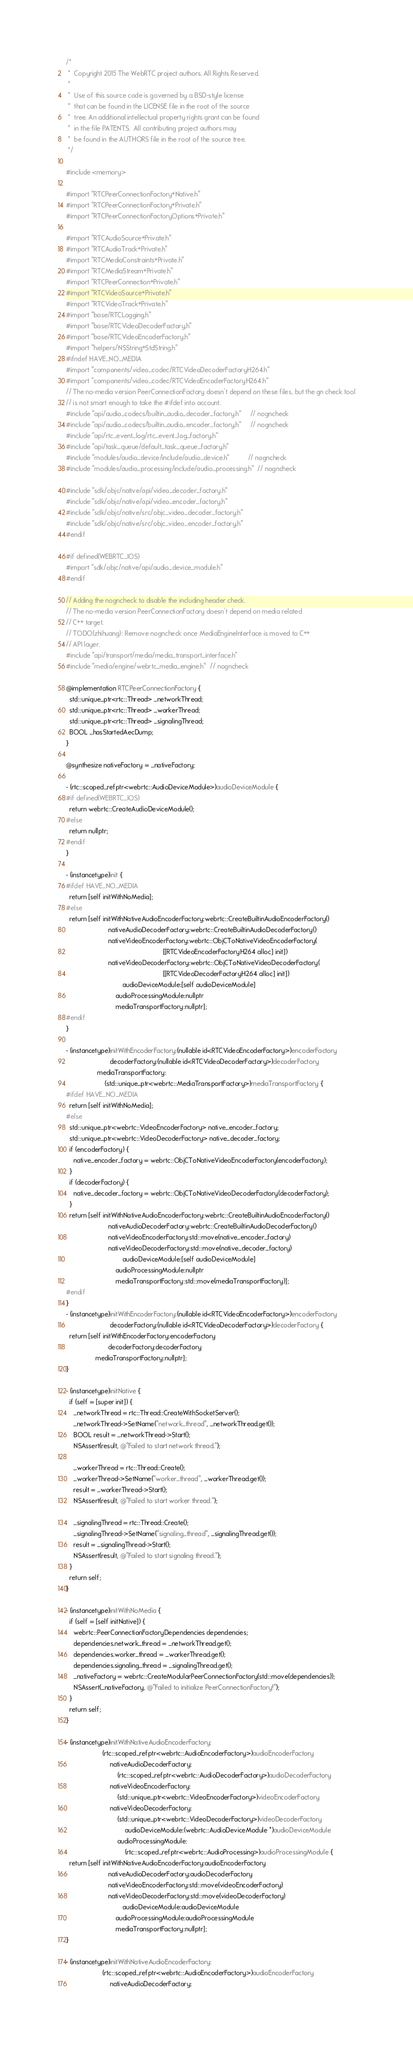<code> <loc_0><loc_0><loc_500><loc_500><_ObjectiveC_>/*
 *  Copyright 2015 The WebRTC project authors. All Rights Reserved.
 *
 *  Use of this source code is governed by a BSD-style license
 *  that can be found in the LICENSE file in the root of the source
 *  tree. An additional intellectual property rights grant can be found
 *  in the file PATENTS.  All contributing project authors may
 *  be found in the AUTHORS file in the root of the source tree.
 */

#include <memory>

#import "RTCPeerConnectionFactory+Native.h"
#import "RTCPeerConnectionFactory+Private.h"
#import "RTCPeerConnectionFactoryOptions+Private.h"

#import "RTCAudioSource+Private.h"
#import "RTCAudioTrack+Private.h"
#import "RTCMediaConstraints+Private.h"
#import "RTCMediaStream+Private.h"
#import "RTCPeerConnection+Private.h"
#import "RTCVideoSource+Private.h"
#import "RTCVideoTrack+Private.h"
#import "base/RTCLogging.h"
#import "base/RTCVideoDecoderFactory.h"
#import "base/RTCVideoEncoderFactory.h"
#import "helpers/NSString+StdString.h"
#ifndef HAVE_NO_MEDIA
#import "components/video_codec/RTCVideoDecoderFactoryH264.h"
#import "components/video_codec/RTCVideoEncoderFactoryH264.h"
// The no-media version PeerConnectionFactory doesn't depend on these files, but the gn check tool
// is not smart enough to take the #ifdef into account.
#include "api/audio_codecs/builtin_audio_decoder_factory.h"     // nogncheck
#include "api/audio_codecs/builtin_audio_encoder_factory.h"     // nogncheck
#include "api/rtc_event_log/rtc_event_log_factory.h"
#include "api/task_queue/default_task_queue_factory.h"
#include "modules/audio_device/include/audio_device.h"          // nogncheck
#include "modules/audio_processing/include/audio_processing.h"  // nogncheck

#include "sdk/objc/native/api/video_decoder_factory.h"
#include "sdk/objc/native/api/video_encoder_factory.h"
#include "sdk/objc/native/src/objc_video_decoder_factory.h"
#include "sdk/objc/native/src/objc_video_encoder_factory.h"
#endif

#if defined(WEBRTC_IOS)
#import "sdk/objc/native/api/audio_device_module.h"
#endif

// Adding the nogncheck to disable the including header check.
// The no-media version PeerConnectionFactory doesn't depend on media related
// C++ target.
// TODO(zhihuang): Remove nogncheck once MediaEngineInterface is moved to C++
// API layer.
#include "api/transport/media/media_transport_interface.h"
#include "media/engine/webrtc_media_engine.h"  // nogncheck

@implementation RTCPeerConnectionFactory {
  std::unique_ptr<rtc::Thread> _networkThread;
  std::unique_ptr<rtc::Thread> _workerThread;
  std::unique_ptr<rtc::Thread> _signalingThread;
  BOOL _hasStartedAecDump;
}

@synthesize nativeFactory = _nativeFactory;

- (rtc::scoped_refptr<webrtc::AudioDeviceModule>)audioDeviceModule {
#if defined(WEBRTC_IOS)
  return webrtc::CreateAudioDeviceModule();
#else
  return nullptr;
#endif
}

- (instancetype)init {
#ifdef HAVE_NO_MEDIA
  return [self initWithNoMedia];
#else
  return [self initWithNativeAudioEncoderFactory:webrtc::CreateBuiltinAudioEncoderFactory()
                       nativeAudioDecoderFactory:webrtc::CreateBuiltinAudioDecoderFactory()
                       nativeVideoEncoderFactory:webrtc::ObjCToNativeVideoEncoderFactory(
                                                     [[RTCVideoEncoderFactoryH264 alloc] init])
                       nativeVideoDecoderFactory:webrtc::ObjCToNativeVideoDecoderFactory(
                                                     [[RTCVideoDecoderFactoryH264 alloc] init])
                               audioDeviceModule:[self audioDeviceModule]
                           audioProcessingModule:nullptr
                           mediaTransportFactory:nullptr];
#endif
}

- (instancetype)initWithEncoderFactory:(nullable id<RTCVideoEncoderFactory>)encoderFactory
                        decoderFactory:(nullable id<RTCVideoDecoderFactory>)decoderFactory
                 mediaTransportFactory:
                     (std::unique_ptr<webrtc::MediaTransportFactory>)mediaTransportFactory {
#ifdef HAVE_NO_MEDIA
  return [self initWithNoMedia];
#else
  std::unique_ptr<webrtc::VideoEncoderFactory> native_encoder_factory;
  std::unique_ptr<webrtc::VideoDecoderFactory> native_decoder_factory;
  if (encoderFactory) {
    native_encoder_factory = webrtc::ObjCToNativeVideoEncoderFactory(encoderFactory);
  }
  if (decoderFactory) {
    native_decoder_factory = webrtc::ObjCToNativeVideoDecoderFactory(decoderFactory);
  }
  return [self initWithNativeAudioEncoderFactory:webrtc::CreateBuiltinAudioEncoderFactory()
                       nativeAudioDecoderFactory:webrtc::CreateBuiltinAudioDecoderFactory()
                       nativeVideoEncoderFactory:std::move(native_encoder_factory)
                       nativeVideoDecoderFactory:std::move(native_decoder_factory)
                               audioDeviceModule:[self audioDeviceModule]
                           audioProcessingModule:nullptr
                           mediaTransportFactory:std::move(mediaTransportFactory)];
#endif
}
- (instancetype)initWithEncoderFactory:(nullable id<RTCVideoEncoderFactory>)encoderFactory
                        decoderFactory:(nullable id<RTCVideoDecoderFactory>)decoderFactory {
  return [self initWithEncoderFactory:encoderFactory
                       decoderFactory:decoderFactory
                mediaTransportFactory:nullptr];
}

- (instancetype)initNative {
  if (self = [super init]) {
    _networkThread = rtc::Thread::CreateWithSocketServer();
    _networkThread->SetName("network_thread", _networkThread.get());
    BOOL result = _networkThread->Start();
    NSAssert(result, @"Failed to start network thread.");

    _workerThread = rtc::Thread::Create();
    _workerThread->SetName("worker_thread", _workerThread.get());
    result = _workerThread->Start();
    NSAssert(result, @"Failed to start worker thread.");

    _signalingThread = rtc::Thread::Create();
    _signalingThread->SetName("signaling_thread", _signalingThread.get());
    result = _signalingThread->Start();
    NSAssert(result, @"Failed to start signaling thread.");
  }
  return self;
}

- (instancetype)initWithNoMedia {
  if (self = [self initNative]) {
    webrtc::PeerConnectionFactoryDependencies dependencies;
    dependencies.network_thread = _networkThread.get();
    dependencies.worker_thread = _workerThread.get();
    dependencies.signaling_thread = _signalingThread.get();
    _nativeFactory = webrtc::CreateModularPeerConnectionFactory(std::move(dependencies));
    NSAssert(_nativeFactory, @"Failed to initialize PeerConnectionFactory!");
  }
  return self;
}

- (instancetype)initWithNativeAudioEncoderFactory:
                    (rtc::scoped_refptr<webrtc::AudioEncoderFactory>)audioEncoderFactory
                        nativeAudioDecoderFactory:
                            (rtc::scoped_refptr<webrtc::AudioDecoderFactory>)audioDecoderFactory
                        nativeVideoEncoderFactory:
                            (std::unique_ptr<webrtc::VideoEncoderFactory>)videoEncoderFactory
                        nativeVideoDecoderFactory:
                            (std::unique_ptr<webrtc::VideoDecoderFactory>)videoDecoderFactory
                                audioDeviceModule:(webrtc::AudioDeviceModule *)audioDeviceModule
                            audioProcessingModule:
                                (rtc::scoped_refptr<webrtc::AudioProcessing>)audioProcessingModule {
  return [self initWithNativeAudioEncoderFactory:audioEncoderFactory
                       nativeAudioDecoderFactory:audioDecoderFactory
                       nativeVideoEncoderFactory:std::move(videoEncoderFactory)
                       nativeVideoDecoderFactory:std::move(videoDecoderFactory)
                               audioDeviceModule:audioDeviceModule
                           audioProcessingModule:audioProcessingModule
                           mediaTransportFactory:nullptr];
}

- (instancetype)initWithNativeAudioEncoderFactory:
                    (rtc::scoped_refptr<webrtc::AudioEncoderFactory>)audioEncoderFactory
                        nativeAudioDecoderFactory:</code> 